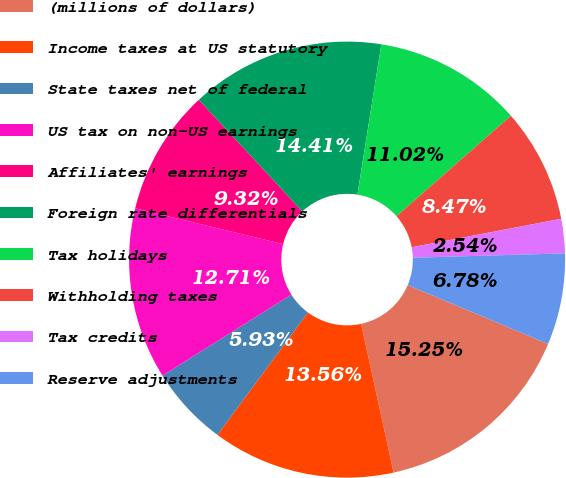<chart> <loc_0><loc_0><loc_500><loc_500><pie_chart><fcel>(millions of dollars)<fcel>Income taxes at US statutory<fcel>State taxes net of federal<fcel>US tax on non-US earnings<fcel>Affiliates' earnings<fcel>Foreign rate differentials<fcel>Tax holidays<fcel>Withholding taxes<fcel>Tax credits<fcel>Reserve adjustments<nl><fcel>15.25%<fcel>13.56%<fcel>5.93%<fcel>12.71%<fcel>9.32%<fcel>14.41%<fcel>11.02%<fcel>8.47%<fcel>2.54%<fcel>6.78%<nl></chart> 